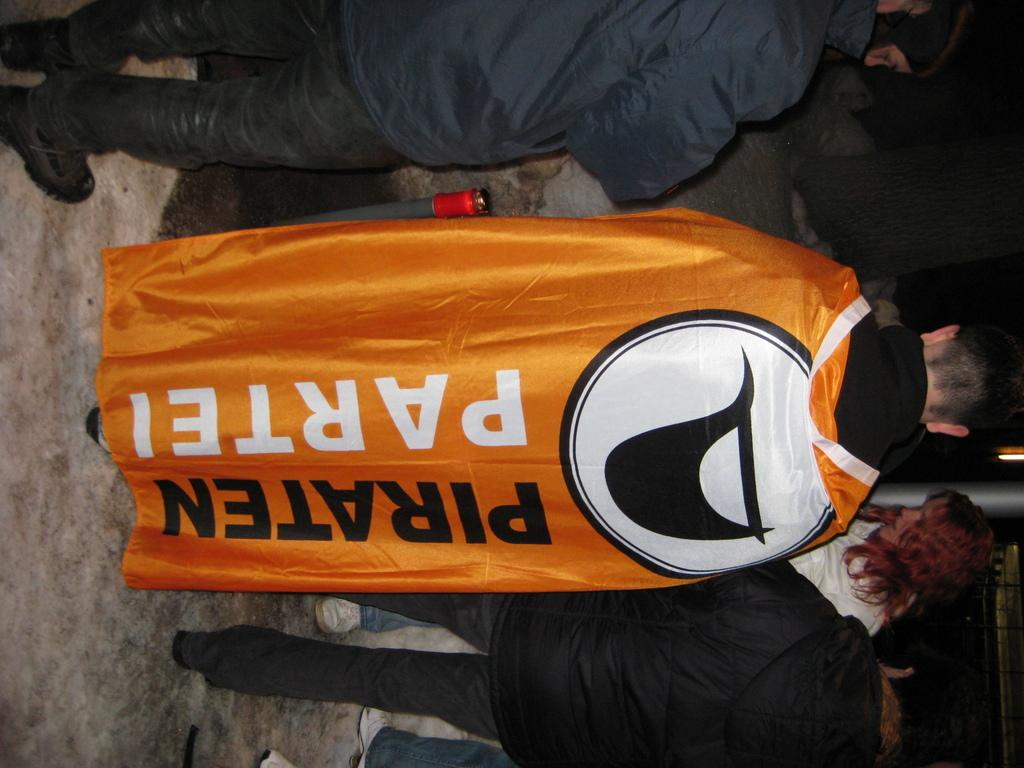How many people are in the image? There is a group of people in the image. Can you describe the clothing of one person in the group? One person in the group is wearing a yellow and black dress. What can be seen in the background of the image? There is a pole visible in the background of the image. What type of skin is visible on the people in the image? There is no mention of skin in the image, so it cannot be determined. 